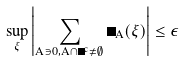Convert formula to latex. <formula><loc_0><loc_0><loc_500><loc_500>\sup _ { \xi } \left | \sum _ { A \ni 0 , A \cap \Delta ^ { c } \neq \emptyset } \Phi _ { A } ( \xi ) \right | \leq \epsilon</formula> 